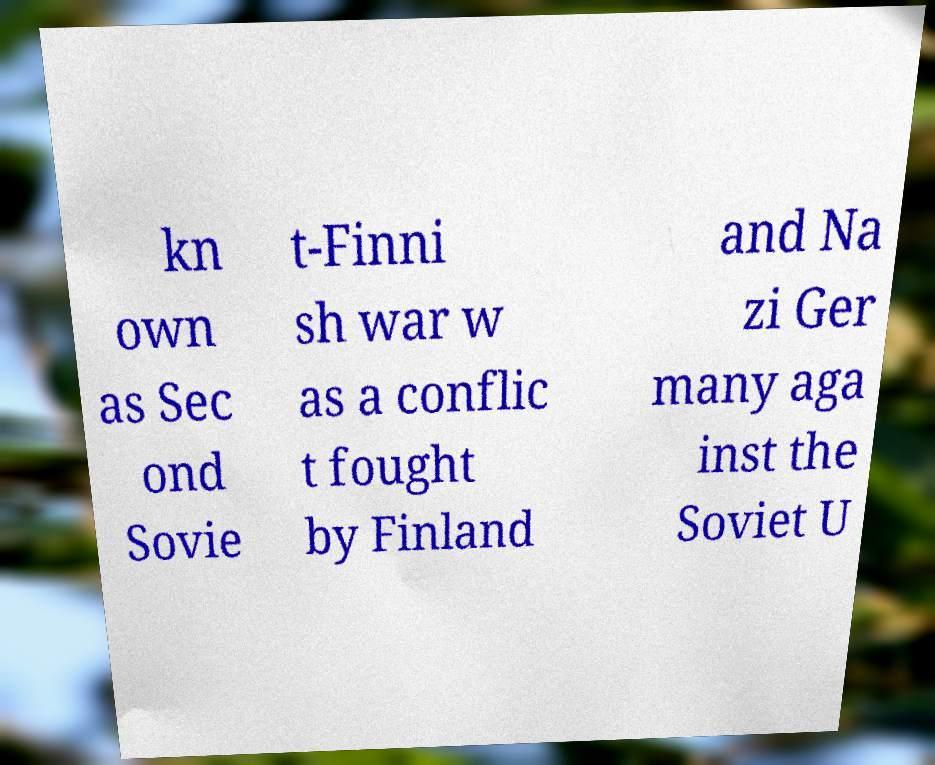Could you assist in decoding the text presented in this image and type it out clearly? kn own as Sec ond Sovie t-Finni sh war w as a conflic t fought by Finland and Na zi Ger many aga inst the Soviet U 